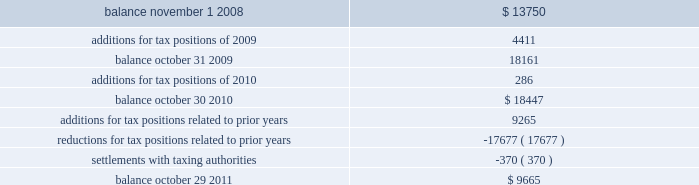The table summarizes the changes in the total amounts of unrealized tax benefits for fiscal 2009 through fiscal 2011. .
Fiscal years 2004 and 2005 irs examination during the fourth quarter of fiscal 2007 , the internal revenue service ( irs ) completed its field examination of the company 2019s fiscal years 2004 and 2005 .
On january 2 , 2008 , the irs issued its report for fiscal 2004 and 2005 , which included four proposed adjustments related to these two fiscal years that the company protested to the irs appeals office .
Two of the unresolved matters were one-time issues that pertain to section 965 of the internal revenue code related to the beneficial tax treatment of dividends paid from foreign owned companies under the american jobs creation act .
The other matters pertained to the computation of the research and development ( r&d ) tax credit and certain profits earned from manufacturing activities carried on outside the united states .
The company recorded a tax liability for a portion of the proposed r&d tax credit adjustment .
These four items had an additional potential tax liability of $ 46 million .
The company concluded , based on discussions with its tax advisors , that these items were not likely to result in any additional tax liability .
Therefore , the company did not record a tax liability for these items .
During the second quarter of fiscal 2011 , the company reached settlement with the irs appeals office on three of the four items under protest .
The remaining unresolved matter is a one-time issue pertaining to section 965 of the internal revenue code related to the beneficial tax treatment of dividends from foreign owned companies under the american jobs creation act .
The company will file a petition with the tax court with respect to this open matter .
The potential liability for this adjustment is $ 36.5 million .
The company has concluded , based on discussions with its tax advisors , that this item is not likely to result in any additional tax liability .
Therefore , the company has not recorded any additional tax liability for this issue .
Fiscal years 2006 and 2007 irs examination during the third quarter of fiscal 2009 , the irs completed its field examination of the company 2019s fiscal years 2006 and 2007 .
The irs and the company agreed on the treatment of a number of issues that have been included in an issue resolutions agreement related to the 2006 and 2007 tax returns .
However , no agreement was reached on the tax treatment of a number of issues for the fiscal 2006 and fiscal 2007 years , including the same r&d tax credit and foreign manufacturing issues mentioned above related to fiscal 2004 and 2005 , the pricing of intercompany sales ( transfer pricing ) and the deductibility of certain stock option compensation expenses .
The company recorded taxes related to a portion of the proposed r&d tax credit adjustment .
These four items had an additional potential total tax liability of $ 195 million .
The company concluded , based on discussions with its tax advisors that these items were not likely to result in any additional tax liability .
Therefore , the company did not record any additional tax liability for these items and appealed these proposed adjustments through the normal processes for the resolution of differences between the irs and taxpayers .
During the second quarter of fiscal 2011 , the company reached an agreement with the irs appeals office on three of the four protested items , two of which were the same issues settled relating to the 2004 and 2005 fiscal years .
Transfer pricing remained as the only item under protest with the irs appeals office related to the fiscal analog devices , inc .
Notes to consolidated financial statements 2014 ( continued ) .
What is the net change in unrealized tax benefits from 2008 to 2011? 
Computations: (9665 - 13750)
Answer: -4085.0. 